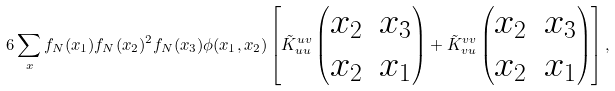<formula> <loc_0><loc_0><loc_500><loc_500>6 \sum _ { x } f _ { N } ( x _ { 1 } ) f _ { N } ( x _ { 2 } ) ^ { 2 } f _ { N } ( x _ { 3 } ) \phi ( x _ { 1 } , x _ { 2 } ) \left [ \tilde { K } _ { u u } ^ { u v } \left ( \begin{matrix} x _ { 2 } & x _ { 3 } \\ x _ { 2 } & x _ { 1 } \end{matrix} \right ) + \tilde { K } _ { v u } ^ { v v } \left ( \begin{matrix} x _ { 2 } & x _ { 3 } \\ x _ { 2 } & x _ { 1 } \end{matrix} \right ) \right ] ,</formula> 